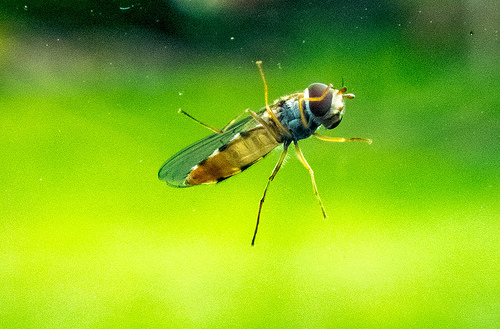<image>
Is there a dirt behind the fly? No. The dirt is not behind the fly. From this viewpoint, the dirt appears to be positioned elsewhere in the scene. 